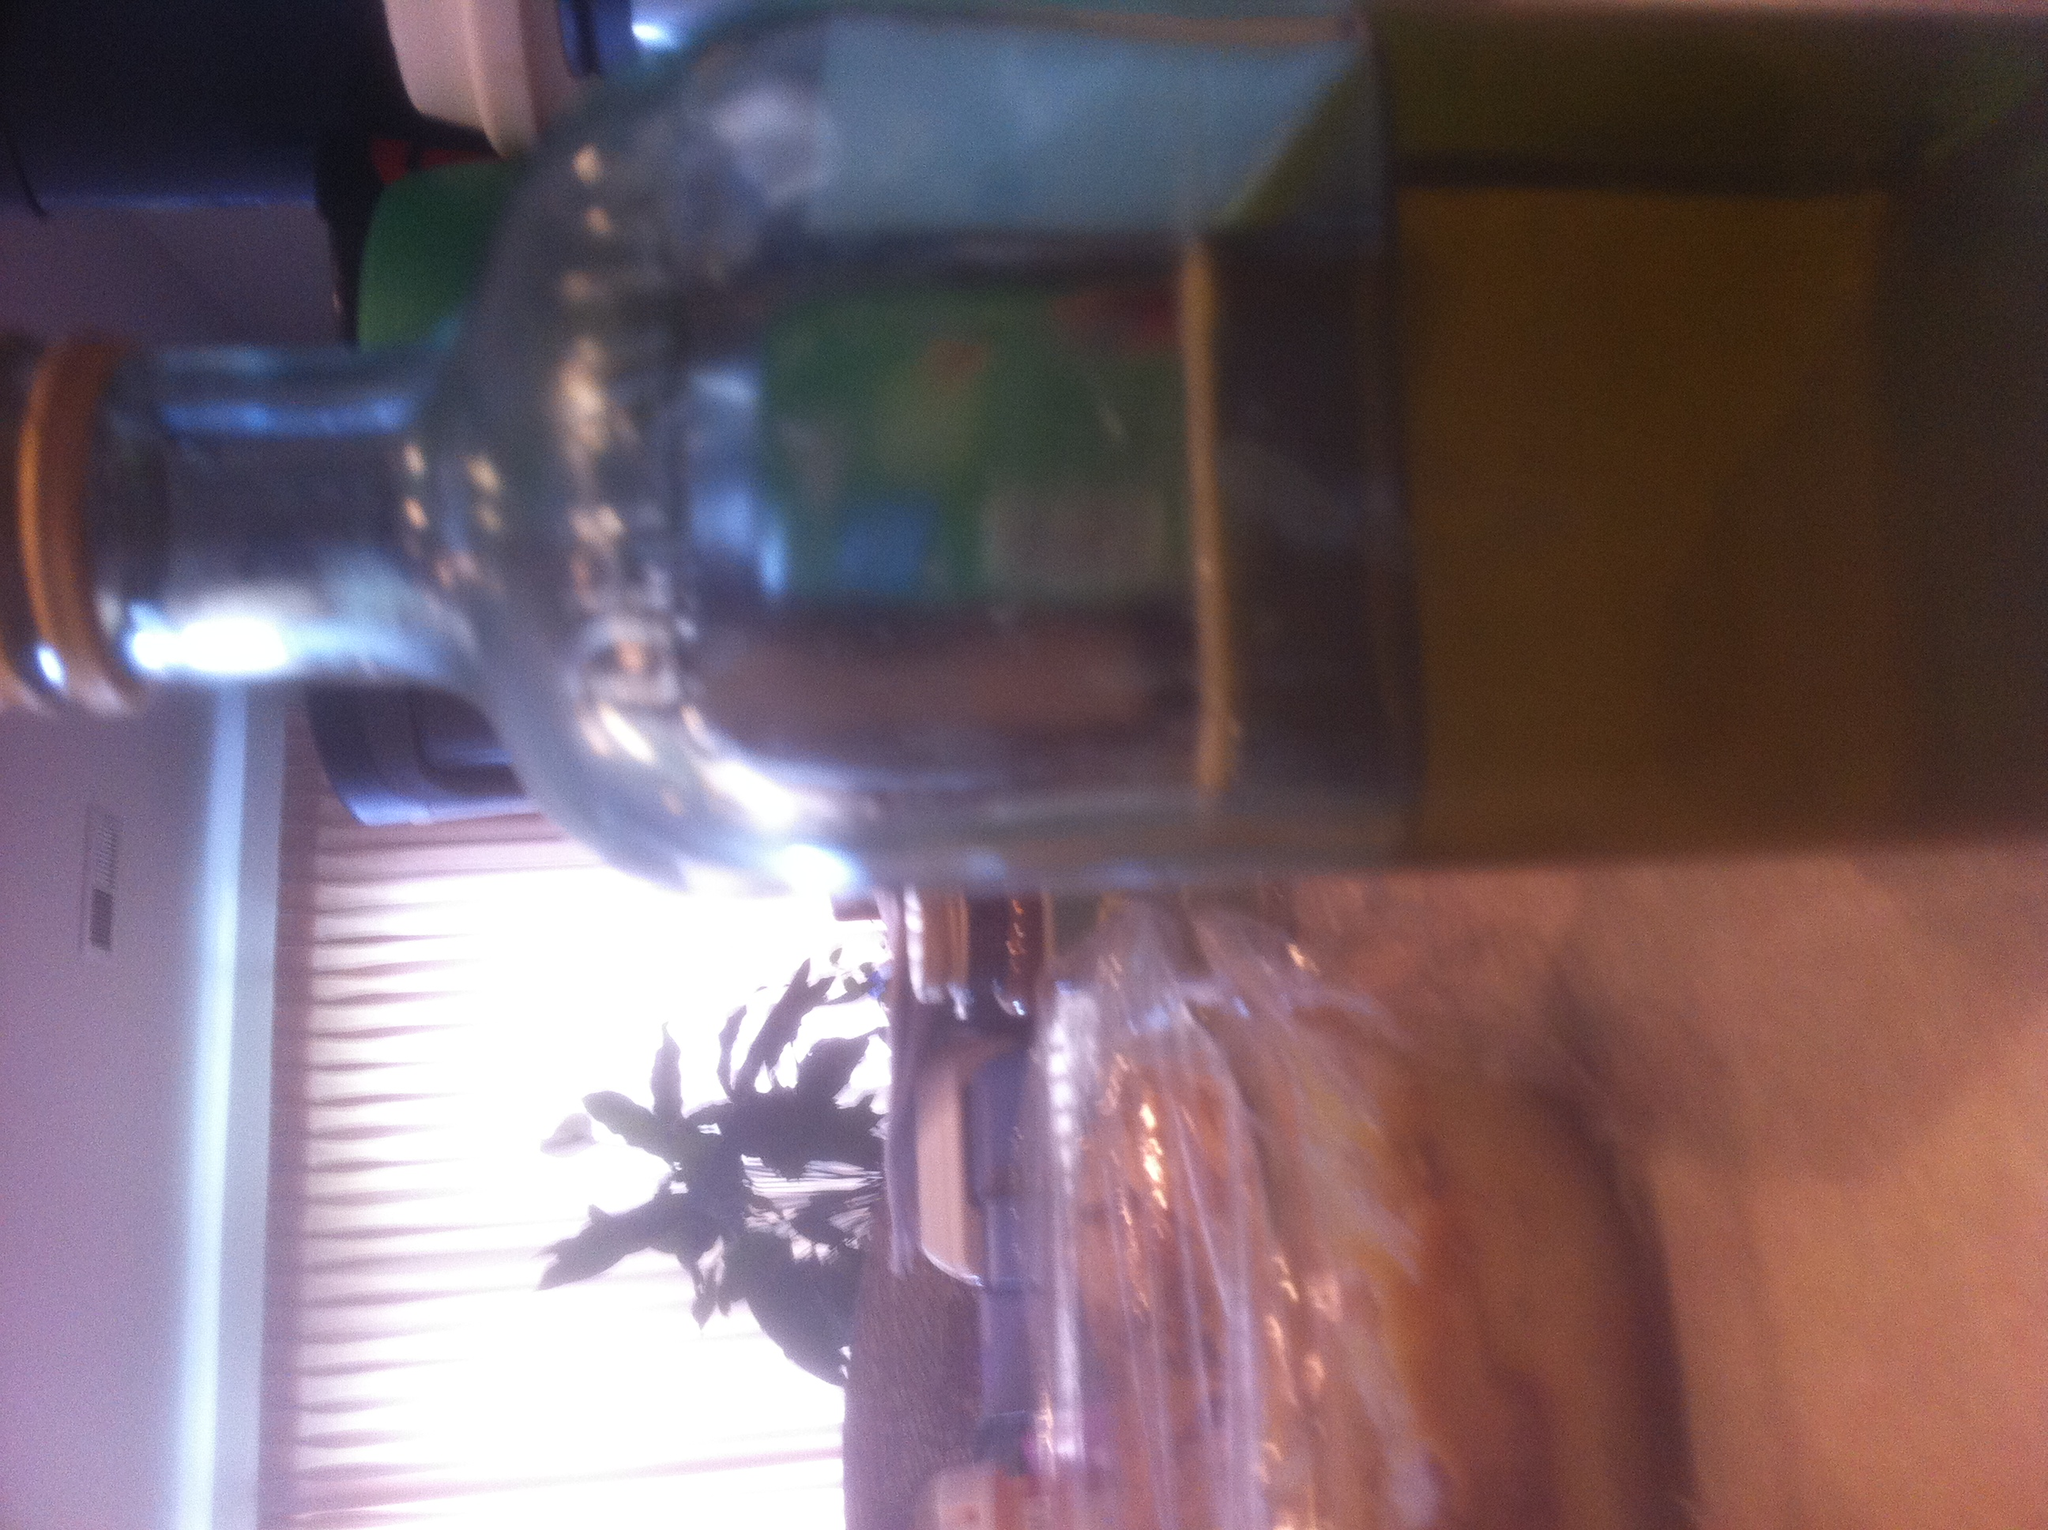How might this bottle be used in a culinary context? This bottle could be used in several culinary contexts. If it contains oil, it might be used for cooking, salad dressings, or drizzling over a dish to add flavor. If it's filled with vinegar, it could serve as an ingredient in marinades, dressings, or for pickling foods. The specific use would depend on the contents, but glass bottles like this are versatile kitchen tools. 